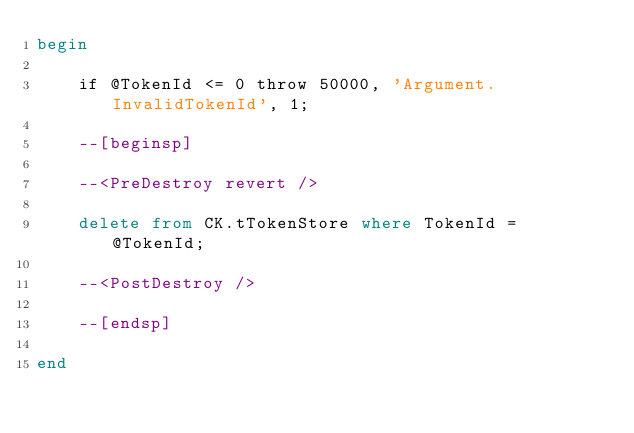<code> <loc_0><loc_0><loc_500><loc_500><_SQL_>begin

    if @TokenId <= 0 throw 50000, 'Argument.InvalidTokenId', 1;

    --[beginsp]

    --<PreDestroy revert />

    delete from CK.tTokenStore where TokenId = @TokenId;

    --<PostDestroy />

    --[endsp]

end
</code> 